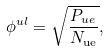<formula> <loc_0><loc_0><loc_500><loc_500>\phi ^ { u l } = \sqrt { \frac { P _ { u e } } { N _ { \mathrm { u e } } } } ,</formula> 